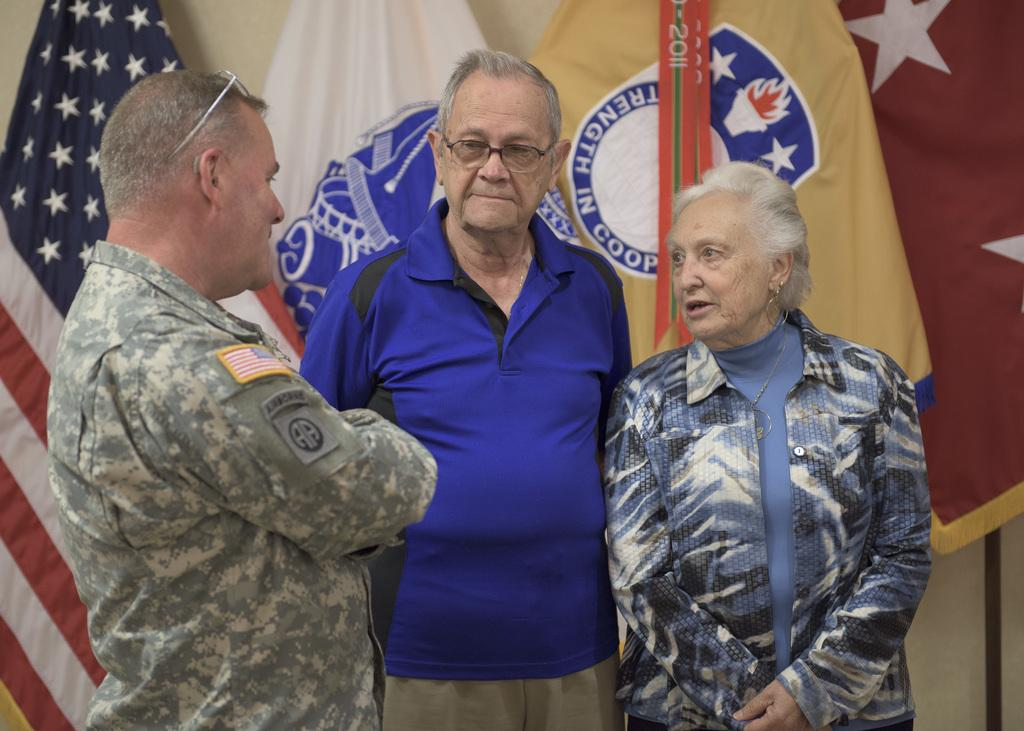How many people are in the image? There are three persons standing in the image. What is the person in front wearing? The person in front is wearing a blue shirt and cream pants. What can be seen in the background of the image? There are flags in the background of the image. What colors are present on the flags? The flags have colors including cream, white, blue, and red. Is there an alley where the three persons are standing in the image? There is no alley present in the image; it appears to be an open area with flags in the background. What type of rock can be seen in the image? There is no rock visible in the image. 